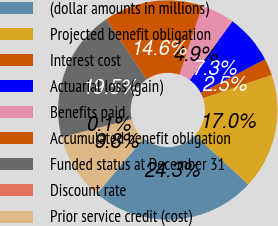Convert chart. <chart><loc_0><loc_0><loc_500><loc_500><pie_chart><fcel>(dollar amounts in millions)<fcel>Projected benefit obligation<fcel>Interest cost<fcel>Actuarial loss (gain)<fcel>Benefits paid<fcel>Accumulated benefit obligation<fcel>Funded status at December 31<fcel>Discount rate<fcel>Prior service credit (cost)<nl><fcel>24.32%<fcel>17.04%<fcel>2.48%<fcel>7.34%<fcel>4.91%<fcel>14.62%<fcel>19.47%<fcel>0.06%<fcel>9.76%<nl></chart> 